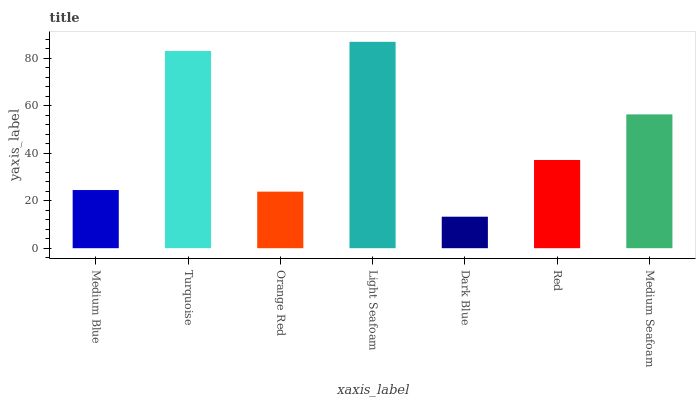Is Dark Blue the minimum?
Answer yes or no. Yes. Is Light Seafoam the maximum?
Answer yes or no. Yes. Is Turquoise the minimum?
Answer yes or no. No. Is Turquoise the maximum?
Answer yes or no. No. Is Turquoise greater than Medium Blue?
Answer yes or no. Yes. Is Medium Blue less than Turquoise?
Answer yes or no. Yes. Is Medium Blue greater than Turquoise?
Answer yes or no. No. Is Turquoise less than Medium Blue?
Answer yes or no. No. Is Red the high median?
Answer yes or no. Yes. Is Red the low median?
Answer yes or no. Yes. Is Medium Blue the high median?
Answer yes or no. No. Is Light Seafoam the low median?
Answer yes or no. No. 